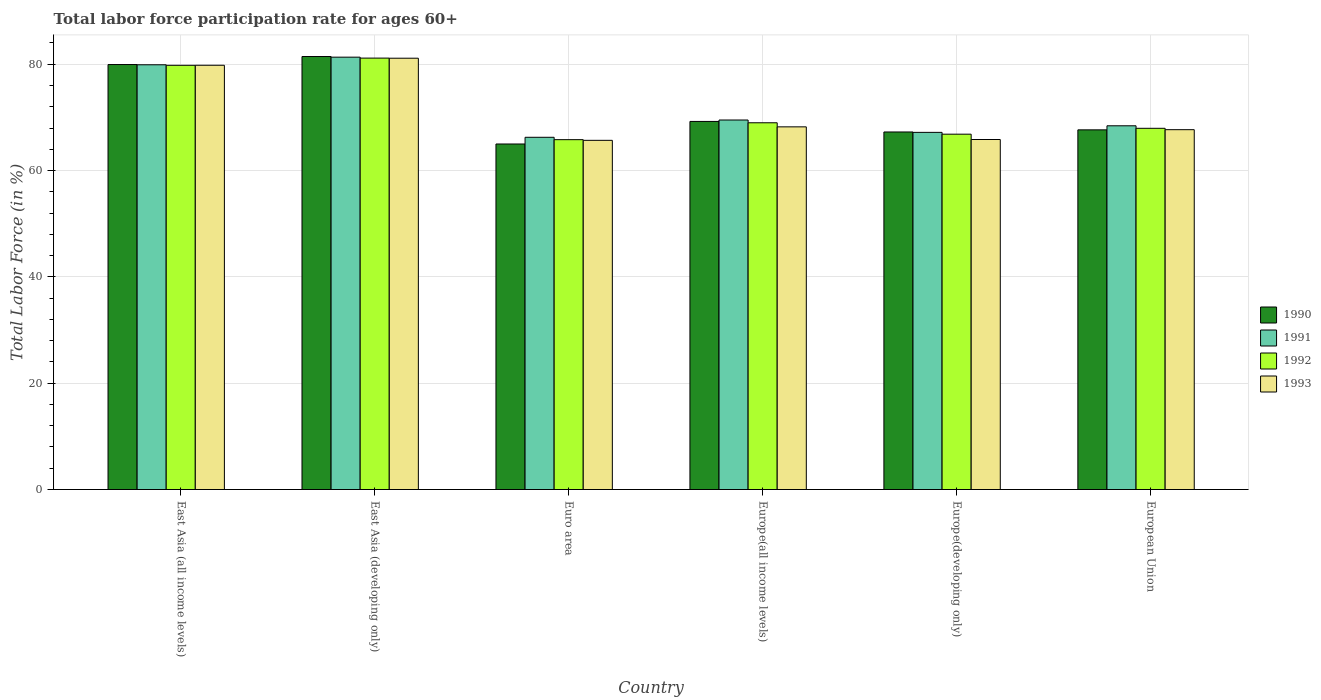How many different coloured bars are there?
Keep it short and to the point. 4. How many groups of bars are there?
Make the answer very short. 6. Are the number of bars per tick equal to the number of legend labels?
Ensure brevity in your answer.  Yes. How many bars are there on the 5th tick from the left?
Give a very brief answer. 4. What is the label of the 2nd group of bars from the left?
Your answer should be very brief. East Asia (developing only). What is the labor force participation rate in 1993 in East Asia (all income levels)?
Make the answer very short. 79.81. Across all countries, what is the maximum labor force participation rate in 1993?
Make the answer very short. 81.14. Across all countries, what is the minimum labor force participation rate in 1990?
Provide a succinct answer. 65. In which country was the labor force participation rate in 1992 maximum?
Keep it short and to the point. East Asia (developing only). In which country was the labor force participation rate in 1993 minimum?
Keep it short and to the point. Euro area. What is the total labor force participation rate in 1993 in the graph?
Offer a very short reply. 428.39. What is the difference between the labor force participation rate in 1992 in East Asia (all income levels) and that in East Asia (developing only)?
Offer a terse response. -1.36. What is the difference between the labor force participation rate in 1992 in Europe(all income levels) and the labor force participation rate in 1993 in East Asia (developing only)?
Provide a succinct answer. -12.15. What is the average labor force participation rate in 1991 per country?
Give a very brief answer. 72.1. What is the difference between the labor force participation rate of/in 1990 and labor force participation rate of/in 1993 in Europe(all income levels)?
Your response must be concise. 1.02. In how many countries, is the labor force participation rate in 1993 greater than 60 %?
Keep it short and to the point. 6. What is the ratio of the labor force participation rate in 1991 in East Asia (all income levels) to that in East Asia (developing only)?
Make the answer very short. 0.98. What is the difference between the highest and the second highest labor force participation rate in 1990?
Give a very brief answer. 12.21. What is the difference between the highest and the lowest labor force participation rate in 1990?
Offer a very short reply. 16.45. What does the 4th bar from the left in Euro area represents?
Offer a very short reply. 1993. Is it the case that in every country, the sum of the labor force participation rate in 1993 and labor force participation rate in 1990 is greater than the labor force participation rate in 1992?
Make the answer very short. Yes. How many bars are there?
Your response must be concise. 24. Are all the bars in the graph horizontal?
Your response must be concise. No. Are the values on the major ticks of Y-axis written in scientific E-notation?
Offer a very short reply. No. Does the graph contain any zero values?
Provide a succinct answer. No. Where does the legend appear in the graph?
Your answer should be compact. Center right. What is the title of the graph?
Ensure brevity in your answer.  Total labor force participation rate for ages 60+. What is the label or title of the Y-axis?
Provide a short and direct response. Total Labor Force (in %). What is the Total Labor Force (in %) in 1990 in East Asia (all income levels)?
Your answer should be compact. 79.95. What is the Total Labor Force (in %) in 1991 in East Asia (all income levels)?
Offer a very short reply. 79.9. What is the Total Labor Force (in %) of 1992 in East Asia (all income levels)?
Provide a succinct answer. 79.8. What is the Total Labor Force (in %) of 1993 in East Asia (all income levels)?
Give a very brief answer. 79.81. What is the Total Labor Force (in %) of 1990 in East Asia (developing only)?
Provide a succinct answer. 81.45. What is the Total Labor Force (in %) of 1991 in East Asia (developing only)?
Provide a succinct answer. 81.33. What is the Total Labor Force (in %) in 1992 in East Asia (developing only)?
Your answer should be compact. 81.16. What is the Total Labor Force (in %) in 1993 in East Asia (developing only)?
Ensure brevity in your answer.  81.14. What is the Total Labor Force (in %) of 1990 in Euro area?
Your response must be concise. 65. What is the Total Labor Force (in %) in 1991 in Euro area?
Provide a succinct answer. 66.26. What is the Total Labor Force (in %) in 1992 in Euro area?
Offer a very short reply. 65.81. What is the Total Labor Force (in %) in 1993 in Euro area?
Provide a succinct answer. 65.69. What is the Total Labor Force (in %) in 1990 in Europe(all income levels)?
Keep it short and to the point. 69.24. What is the Total Labor Force (in %) in 1991 in Europe(all income levels)?
Keep it short and to the point. 69.51. What is the Total Labor Force (in %) in 1992 in Europe(all income levels)?
Ensure brevity in your answer.  68.99. What is the Total Labor Force (in %) in 1993 in Europe(all income levels)?
Offer a very short reply. 68.22. What is the Total Labor Force (in %) in 1990 in Europe(developing only)?
Make the answer very short. 67.26. What is the Total Labor Force (in %) in 1991 in Europe(developing only)?
Provide a short and direct response. 67.19. What is the Total Labor Force (in %) of 1992 in Europe(developing only)?
Offer a terse response. 66.85. What is the Total Labor Force (in %) in 1993 in Europe(developing only)?
Your answer should be very brief. 65.84. What is the Total Labor Force (in %) of 1990 in European Union?
Provide a short and direct response. 67.66. What is the Total Labor Force (in %) in 1991 in European Union?
Keep it short and to the point. 68.42. What is the Total Labor Force (in %) of 1992 in European Union?
Your answer should be compact. 67.95. What is the Total Labor Force (in %) in 1993 in European Union?
Your answer should be compact. 67.69. Across all countries, what is the maximum Total Labor Force (in %) of 1990?
Ensure brevity in your answer.  81.45. Across all countries, what is the maximum Total Labor Force (in %) of 1991?
Your answer should be compact. 81.33. Across all countries, what is the maximum Total Labor Force (in %) in 1992?
Provide a succinct answer. 81.16. Across all countries, what is the maximum Total Labor Force (in %) in 1993?
Keep it short and to the point. 81.14. Across all countries, what is the minimum Total Labor Force (in %) in 1990?
Your response must be concise. 65. Across all countries, what is the minimum Total Labor Force (in %) in 1991?
Keep it short and to the point. 66.26. Across all countries, what is the minimum Total Labor Force (in %) in 1992?
Offer a very short reply. 65.81. Across all countries, what is the minimum Total Labor Force (in %) of 1993?
Your answer should be very brief. 65.69. What is the total Total Labor Force (in %) in 1990 in the graph?
Keep it short and to the point. 430.56. What is the total Total Labor Force (in %) of 1991 in the graph?
Your answer should be very brief. 432.61. What is the total Total Labor Force (in %) of 1992 in the graph?
Your response must be concise. 430.56. What is the total Total Labor Force (in %) in 1993 in the graph?
Ensure brevity in your answer.  428.39. What is the difference between the Total Labor Force (in %) of 1990 in East Asia (all income levels) and that in East Asia (developing only)?
Offer a very short reply. -1.51. What is the difference between the Total Labor Force (in %) of 1991 in East Asia (all income levels) and that in East Asia (developing only)?
Offer a very short reply. -1.43. What is the difference between the Total Labor Force (in %) in 1992 in East Asia (all income levels) and that in East Asia (developing only)?
Make the answer very short. -1.36. What is the difference between the Total Labor Force (in %) of 1993 in East Asia (all income levels) and that in East Asia (developing only)?
Keep it short and to the point. -1.33. What is the difference between the Total Labor Force (in %) of 1990 in East Asia (all income levels) and that in Euro area?
Your answer should be compact. 14.95. What is the difference between the Total Labor Force (in %) in 1991 in East Asia (all income levels) and that in Euro area?
Your response must be concise. 13.64. What is the difference between the Total Labor Force (in %) of 1992 in East Asia (all income levels) and that in Euro area?
Your response must be concise. 13.99. What is the difference between the Total Labor Force (in %) in 1993 in East Asia (all income levels) and that in Euro area?
Provide a short and direct response. 14.12. What is the difference between the Total Labor Force (in %) of 1990 in East Asia (all income levels) and that in Europe(all income levels)?
Ensure brevity in your answer.  10.7. What is the difference between the Total Labor Force (in %) in 1991 in East Asia (all income levels) and that in Europe(all income levels)?
Offer a terse response. 10.39. What is the difference between the Total Labor Force (in %) of 1992 in East Asia (all income levels) and that in Europe(all income levels)?
Offer a very short reply. 10.81. What is the difference between the Total Labor Force (in %) in 1993 in East Asia (all income levels) and that in Europe(all income levels)?
Provide a succinct answer. 11.59. What is the difference between the Total Labor Force (in %) in 1990 in East Asia (all income levels) and that in Europe(developing only)?
Ensure brevity in your answer.  12.69. What is the difference between the Total Labor Force (in %) of 1991 in East Asia (all income levels) and that in Europe(developing only)?
Provide a short and direct response. 12.71. What is the difference between the Total Labor Force (in %) in 1992 in East Asia (all income levels) and that in Europe(developing only)?
Make the answer very short. 12.96. What is the difference between the Total Labor Force (in %) of 1993 in East Asia (all income levels) and that in Europe(developing only)?
Provide a succinct answer. 13.97. What is the difference between the Total Labor Force (in %) of 1990 in East Asia (all income levels) and that in European Union?
Offer a very short reply. 12.29. What is the difference between the Total Labor Force (in %) of 1991 in East Asia (all income levels) and that in European Union?
Your answer should be compact. 11.48. What is the difference between the Total Labor Force (in %) of 1992 in East Asia (all income levels) and that in European Union?
Your response must be concise. 11.85. What is the difference between the Total Labor Force (in %) of 1993 in East Asia (all income levels) and that in European Union?
Your answer should be very brief. 12.12. What is the difference between the Total Labor Force (in %) of 1990 in East Asia (developing only) and that in Euro area?
Give a very brief answer. 16.45. What is the difference between the Total Labor Force (in %) in 1991 in East Asia (developing only) and that in Euro area?
Your answer should be very brief. 15.07. What is the difference between the Total Labor Force (in %) in 1992 in East Asia (developing only) and that in Euro area?
Your answer should be very brief. 15.34. What is the difference between the Total Labor Force (in %) in 1993 in East Asia (developing only) and that in Euro area?
Give a very brief answer. 15.45. What is the difference between the Total Labor Force (in %) in 1990 in East Asia (developing only) and that in Europe(all income levels)?
Offer a terse response. 12.21. What is the difference between the Total Labor Force (in %) in 1991 in East Asia (developing only) and that in Europe(all income levels)?
Your response must be concise. 11.82. What is the difference between the Total Labor Force (in %) of 1992 in East Asia (developing only) and that in Europe(all income levels)?
Your response must be concise. 12.17. What is the difference between the Total Labor Force (in %) in 1993 in East Asia (developing only) and that in Europe(all income levels)?
Your answer should be very brief. 12.91. What is the difference between the Total Labor Force (in %) of 1990 in East Asia (developing only) and that in Europe(developing only)?
Provide a short and direct response. 14.2. What is the difference between the Total Labor Force (in %) of 1991 in East Asia (developing only) and that in Europe(developing only)?
Ensure brevity in your answer.  14.14. What is the difference between the Total Labor Force (in %) in 1992 in East Asia (developing only) and that in Europe(developing only)?
Your answer should be very brief. 14.31. What is the difference between the Total Labor Force (in %) in 1993 in East Asia (developing only) and that in Europe(developing only)?
Offer a very short reply. 15.29. What is the difference between the Total Labor Force (in %) in 1990 in East Asia (developing only) and that in European Union?
Ensure brevity in your answer.  13.79. What is the difference between the Total Labor Force (in %) in 1991 in East Asia (developing only) and that in European Union?
Offer a very short reply. 12.91. What is the difference between the Total Labor Force (in %) of 1992 in East Asia (developing only) and that in European Union?
Offer a terse response. 13.21. What is the difference between the Total Labor Force (in %) in 1993 in East Asia (developing only) and that in European Union?
Offer a very short reply. 13.45. What is the difference between the Total Labor Force (in %) of 1990 in Euro area and that in Europe(all income levels)?
Provide a succinct answer. -4.24. What is the difference between the Total Labor Force (in %) in 1991 in Euro area and that in Europe(all income levels)?
Keep it short and to the point. -3.25. What is the difference between the Total Labor Force (in %) in 1992 in Euro area and that in Europe(all income levels)?
Your response must be concise. -3.18. What is the difference between the Total Labor Force (in %) of 1993 in Euro area and that in Europe(all income levels)?
Your answer should be very brief. -2.54. What is the difference between the Total Labor Force (in %) in 1990 in Euro area and that in Europe(developing only)?
Offer a terse response. -2.26. What is the difference between the Total Labor Force (in %) in 1991 in Euro area and that in Europe(developing only)?
Your response must be concise. -0.93. What is the difference between the Total Labor Force (in %) in 1992 in Euro area and that in Europe(developing only)?
Your answer should be compact. -1.03. What is the difference between the Total Labor Force (in %) in 1993 in Euro area and that in Europe(developing only)?
Ensure brevity in your answer.  -0.16. What is the difference between the Total Labor Force (in %) of 1990 in Euro area and that in European Union?
Give a very brief answer. -2.66. What is the difference between the Total Labor Force (in %) in 1991 in Euro area and that in European Union?
Give a very brief answer. -2.16. What is the difference between the Total Labor Force (in %) of 1992 in Euro area and that in European Union?
Your answer should be compact. -2.14. What is the difference between the Total Labor Force (in %) in 1993 in Euro area and that in European Union?
Your response must be concise. -2.01. What is the difference between the Total Labor Force (in %) in 1990 in Europe(all income levels) and that in Europe(developing only)?
Your answer should be very brief. 1.99. What is the difference between the Total Labor Force (in %) in 1991 in Europe(all income levels) and that in Europe(developing only)?
Provide a short and direct response. 2.33. What is the difference between the Total Labor Force (in %) of 1992 in Europe(all income levels) and that in Europe(developing only)?
Offer a very short reply. 2.15. What is the difference between the Total Labor Force (in %) of 1993 in Europe(all income levels) and that in Europe(developing only)?
Provide a short and direct response. 2.38. What is the difference between the Total Labor Force (in %) of 1990 in Europe(all income levels) and that in European Union?
Offer a terse response. 1.58. What is the difference between the Total Labor Force (in %) of 1991 in Europe(all income levels) and that in European Union?
Offer a very short reply. 1.09. What is the difference between the Total Labor Force (in %) in 1992 in Europe(all income levels) and that in European Union?
Give a very brief answer. 1.04. What is the difference between the Total Labor Force (in %) in 1993 in Europe(all income levels) and that in European Union?
Your response must be concise. 0.53. What is the difference between the Total Labor Force (in %) in 1990 in Europe(developing only) and that in European Union?
Provide a short and direct response. -0.4. What is the difference between the Total Labor Force (in %) of 1991 in Europe(developing only) and that in European Union?
Ensure brevity in your answer.  -1.24. What is the difference between the Total Labor Force (in %) in 1992 in Europe(developing only) and that in European Union?
Your answer should be compact. -1.1. What is the difference between the Total Labor Force (in %) in 1993 in Europe(developing only) and that in European Union?
Keep it short and to the point. -1.85. What is the difference between the Total Labor Force (in %) of 1990 in East Asia (all income levels) and the Total Labor Force (in %) of 1991 in East Asia (developing only)?
Make the answer very short. -1.39. What is the difference between the Total Labor Force (in %) in 1990 in East Asia (all income levels) and the Total Labor Force (in %) in 1992 in East Asia (developing only)?
Make the answer very short. -1.21. What is the difference between the Total Labor Force (in %) of 1990 in East Asia (all income levels) and the Total Labor Force (in %) of 1993 in East Asia (developing only)?
Your answer should be very brief. -1.19. What is the difference between the Total Labor Force (in %) in 1991 in East Asia (all income levels) and the Total Labor Force (in %) in 1992 in East Asia (developing only)?
Make the answer very short. -1.26. What is the difference between the Total Labor Force (in %) in 1991 in East Asia (all income levels) and the Total Labor Force (in %) in 1993 in East Asia (developing only)?
Your response must be concise. -1.24. What is the difference between the Total Labor Force (in %) of 1992 in East Asia (all income levels) and the Total Labor Force (in %) of 1993 in East Asia (developing only)?
Offer a very short reply. -1.34. What is the difference between the Total Labor Force (in %) in 1990 in East Asia (all income levels) and the Total Labor Force (in %) in 1991 in Euro area?
Offer a terse response. 13.69. What is the difference between the Total Labor Force (in %) in 1990 in East Asia (all income levels) and the Total Labor Force (in %) in 1992 in Euro area?
Your answer should be compact. 14.13. What is the difference between the Total Labor Force (in %) in 1990 in East Asia (all income levels) and the Total Labor Force (in %) in 1993 in Euro area?
Give a very brief answer. 14.26. What is the difference between the Total Labor Force (in %) of 1991 in East Asia (all income levels) and the Total Labor Force (in %) of 1992 in Euro area?
Offer a very short reply. 14.09. What is the difference between the Total Labor Force (in %) of 1991 in East Asia (all income levels) and the Total Labor Force (in %) of 1993 in Euro area?
Your answer should be compact. 14.22. What is the difference between the Total Labor Force (in %) in 1992 in East Asia (all income levels) and the Total Labor Force (in %) in 1993 in Euro area?
Your answer should be compact. 14.12. What is the difference between the Total Labor Force (in %) of 1990 in East Asia (all income levels) and the Total Labor Force (in %) of 1991 in Europe(all income levels)?
Your answer should be compact. 10.43. What is the difference between the Total Labor Force (in %) in 1990 in East Asia (all income levels) and the Total Labor Force (in %) in 1992 in Europe(all income levels)?
Your answer should be compact. 10.95. What is the difference between the Total Labor Force (in %) of 1990 in East Asia (all income levels) and the Total Labor Force (in %) of 1993 in Europe(all income levels)?
Provide a short and direct response. 11.72. What is the difference between the Total Labor Force (in %) in 1991 in East Asia (all income levels) and the Total Labor Force (in %) in 1992 in Europe(all income levels)?
Provide a succinct answer. 10.91. What is the difference between the Total Labor Force (in %) of 1991 in East Asia (all income levels) and the Total Labor Force (in %) of 1993 in Europe(all income levels)?
Give a very brief answer. 11.68. What is the difference between the Total Labor Force (in %) in 1992 in East Asia (all income levels) and the Total Labor Force (in %) in 1993 in Europe(all income levels)?
Make the answer very short. 11.58. What is the difference between the Total Labor Force (in %) of 1990 in East Asia (all income levels) and the Total Labor Force (in %) of 1991 in Europe(developing only)?
Give a very brief answer. 12.76. What is the difference between the Total Labor Force (in %) in 1990 in East Asia (all income levels) and the Total Labor Force (in %) in 1992 in Europe(developing only)?
Your response must be concise. 13.1. What is the difference between the Total Labor Force (in %) in 1990 in East Asia (all income levels) and the Total Labor Force (in %) in 1993 in Europe(developing only)?
Your answer should be very brief. 14.1. What is the difference between the Total Labor Force (in %) of 1991 in East Asia (all income levels) and the Total Labor Force (in %) of 1992 in Europe(developing only)?
Give a very brief answer. 13.05. What is the difference between the Total Labor Force (in %) in 1991 in East Asia (all income levels) and the Total Labor Force (in %) in 1993 in Europe(developing only)?
Give a very brief answer. 14.06. What is the difference between the Total Labor Force (in %) of 1992 in East Asia (all income levels) and the Total Labor Force (in %) of 1993 in Europe(developing only)?
Provide a succinct answer. 13.96. What is the difference between the Total Labor Force (in %) in 1990 in East Asia (all income levels) and the Total Labor Force (in %) in 1991 in European Union?
Your answer should be compact. 11.52. What is the difference between the Total Labor Force (in %) of 1990 in East Asia (all income levels) and the Total Labor Force (in %) of 1992 in European Union?
Offer a terse response. 11.99. What is the difference between the Total Labor Force (in %) in 1990 in East Asia (all income levels) and the Total Labor Force (in %) in 1993 in European Union?
Your response must be concise. 12.25. What is the difference between the Total Labor Force (in %) of 1991 in East Asia (all income levels) and the Total Labor Force (in %) of 1992 in European Union?
Offer a terse response. 11.95. What is the difference between the Total Labor Force (in %) of 1991 in East Asia (all income levels) and the Total Labor Force (in %) of 1993 in European Union?
Give a very brief answer. 12.21. What is the difference between the Total Labor Force (in %) of 1992 in East Asia (all income levels) and the Total Labor Force (in %) of 1993 in European Union?
Ensure brevity in your answer.  12.11. What is the difference between the Total Labor Force (in %) in 1990 in East Asia (developing only) and the Total Labor Force (in %) in 1991 in Euro area?
Give a very brief answer. 15.19. What is the difference between the Total Labor Force (in %) in 1990 in East Asia (developing only) and the Total Labor Force (in %) in 1992 in Euro area?
Provide a short and direct response. 15.64. What is the difference between the Total Labor Force (in %) of 1990 in East Asia (developing only) and the Total Labor Force (in %) of 1993 in Euro area?
Your answer should be compact. 15.77. What is the difference between the Total Labor Force (in %) in 1991 in East Asia (developing only) and the Total Labor Force (in %) in 1992 in Euro area?
Make the answer very short. 15.52. What is the difference between the Total Labor Force (in %) of 1991 in East Asia (developing only) and the Total Labor Force (in %) of 1993 in Euro area?
Offer a very short reply. 15.65. What is the difference between the Total Labor Force (in %) in 1992 in East Asia (developing only) and the Total Labor Force (in %) in 1993 in Euro area?
Offer a terse response. 15.47. What is the difference between the Total Labor Force (in %) of 1990 in East Asia (developing only) and the Total Labor Force (in %) of 1991 in Europe(all income levels)?
Give a very brief answer. 11.94. What is the difference between the Total Labor Force (in %) of 1990 in East Asia (developing only) and the Total Labor Force (in %) of 1992 in Europe(all income levels)?
Keep it short and to the point. 12.46. What is the difference between the Total Labor Force (in %) of 1990 in East Asia (developing only) and the Total Labor Force (in %) of 1993 in Europe(all income levels)?
Provide a short and direct response. 13.23. What is the difference between the Total Labor Force (in %) of 1991 in East Asia (developing only) and the Total Labor Force (in %) of 1992 in Europe(all income levels)?
Keep it short and to the point. 12.34. What is the difference between the Total Labor Force (in %) in 1991 in East Asia (developing only) and the Total Labor Force (in %) in 1993 in Europe(all income levels)?
Offer a very short reply. 13.11. What is the difference between the Total Labor Force (in %) in 1992 in East Asia (developing only) and the Total Labor Force (in %) in 1993 in Europe(all income levels)?
Your answer should be compact. 12.93. What is the difference between the Total Labor Force (in %) in 1990 in East Asia (developing only) and the Total Labor Force (in %) in 1991 in Europe(developing only)?
Provide a succinct answer. 14.27. What is the difference between the Total Labor Force (in %) of 1990 in East Asia (developing only) and the Total Labor Force (in %) of 1992 in Europe(developing only)?
Your response must be concise. 14.61. What is the difference between the Total Labor Force (in %) in 1990 in East Asia (developing only) and the Total Labor Force (in %) in 1993 in Europe(developing only)?
Give a very brief answer. 15.61. What is the difference between the Total Labor Force (in %) in 1991 in East Asia (developing only) and the Total Labor Force (in %) in 1992 in Europe(developing only)?
Give a very brief answer. 14.49. What is the difference between the Total Labor Force (in %) of 1991 in East Asia (developing only) and the Total Labor Force (in %) of 1993 in Europe(developing only)?
Make the answer very short. 15.49. What is the difference between the Total Labor Force (in %) of 1992 in East Asia (developing only) and the Total Labor Force (in %) of 1993 in Europe(developing only)?
Your response must be concise. 15.31. What is the difference between the Total Labor Force (in %) of 1990 in East Asia (developing only) and the Total Labor Force (in %) of 1991 in European Union?
Your answer should be compact. 13.03. What is the difference between the Total Labor Force (in %) in 1990 in East Asia (developing only) and the Total Labor Force (in %) in 1992 in European Union?
Ensure brevity in your answer.  13.5. What is the difference between the Total Labor Force (in %) of 1990 in East Asia (developing only) and the Total Labor Force (in %) of 1993 in European Union?
Your answer should be very brief. 13.76. What is the difference between the Total Labor Force (in %) of 1991 in East Asia (developing only) and the Total Labor Force (in %) of 1992 in European Union?
Your answer should be compact. 13.38. What is the difference between the Total Labor Force (in %) of 1991 in East Asia (developing only) and the Total Labor Force (in %) of 1993 in European Union?
Make the answer very short. 13.64. What is the difference between the Total Labor Force (in %) of 1992 in East Asia (developing only) and the Total Labor Force (in %) of 1993 in European Union?
Offer a terse response. 13.47. What is the difference between the Total Labor Force (in %) in 1990 in Euro area and the Total Labor Force (in %) in 1991 in Europe(all income levels)?
Keep it short and to the point. -4.51. What is the difference between the Total Labor Force (in %) of 1990 in Euro area and the Total Labor Force (in %) of 1992 in Europe(all income levels)?
Ensure brevity in your answer.  -3.99. What is the difference between the Total Labor Force (in %) of 1990 in Euro area and the Total Labor Force (in %) of 1993 in Europe(all income levels)?
Give a very brief answer. -3.22. What is the difference between the Total Labor Force (in %) of 1991 in Euro area and the Total Labor Force (in %) of 1992 in Europe(all income levels)?
Make the answer very short. -2.73. What is the difference between the Total Labor Force (in %) of 1991 in Euro area and the Total Labor Force (in %) of 1993 in Europe(all income levels)?
Offer a very short reply. -1.97. What is the difference between the Total Labor Force (in %) in 1992 in Euro area and the Total Labor Force (in %) in 1993 in Europe(all income levels)?
Make the answer very short. -2.41. What is the difference between the Total Labor Force (in %) of 1990 in Euro area and the Total Labor Force (in %) of 1991 in Europe(developing only)?
Make the answer very short. -2.19. What is the difference between the Total Labor Force (in %) in 1990 in Euro area and the Total Labor Force (in %) in 1992 in Europe(developing only)?
Offer a very short reply. -1.85. What is the difference between the Total Labor Force (in %) of 1990 in Euro area and the Total Labor Force (in %) of 1993 in Europe(developing only)?
Provide a succinct answer. -0.84. What is the difference between the Total Labor Force (in %) in 1991 in Euro area and the Total Labor Force (in %) in 1992 in Europe(developing only)?
Your response must be concise. -0.59. What is the difference between the Total Labor Force (in %) in 1991 in Euro area and the Total Labor Force (in %) in 1993 in Europe(developing only)?
Ensure brevity in your answer.  0.42. What is the difference between the Total Labor Force (in %) in 1992 in Euro area and the Total Labor Force (in %) in 1993 in Europe(developing only)?
Ensure brevity in your answer.  -0.03. What is the difference between the Total Labor Force (in %) in 1990 in Euro area and the Total Labor Force (in %) in 1991 in European Union?
Your answer should be compact. -3.42. What is the difference between the Total Labor Force (in %) of 1990 in Euro area and the Total Labor Force (in %) of 1992 in European Union?
Ensure brevity in your answer.  -2.95. What is the difference between the Total Labor Force (in %) of 1990 in Euro area and the Total Labor Force (in %) of 1993 in European Union?
Ensure brevity in your answer.  -2.69. What is the difference between the Total Labor Force (in %) in 1991 in Euro area and the Total Labor Force (in %) in 1992 in European Union?
Provide a succinct answer. -1.69. What is the difference between the Total Labor Force (in %) of 1991 in Euro area and the Total Labor Force (in %) of 1993 in European Union?
Provide a succinct answer. -1.43. What is the difference between the Total Labor Force (in %) in 1992 in Euro area and the Total Labor Force (in %) in 1993 in European Union?
Your response must be concise. -1.88. What is the difference between the Total Labor Force (in %) in 1990 in Europe(all income levels) and the Total Labor Force (in %) in 1991 in Europe(developing only)?
Offer a very short reply. 2.06. What is the difference between the Total Labor Force (in %) of 1990 in Europe(all income levels) and the Total Labor Force (in %) of 1992 in Europe(developing only)?
Offer a very short reply. 2.4. What is the difference between the Total Labor Force (in %) in 1990 in Europe(all income levels) and the Total Labor Force (in %) in 1993 in Europe(developing only)?
Give a very brief answer. 3.4. What is the difference between the Total Labor Force (in %) in 1991 in Europe(all income levels) and the Total Labor Force (in %) in 1992 in Europe(developing only)?
Provide a short and direct response. 2.67. What is the difference between the Total Labor Force (in %) in 1991 in Europe(all income levels) and the Total Labor Force (in %) in 1993 in Europe(developing only)?
Your response must be concise. 3.67. What is the difference between the Total Labor Force (in %) in 1992 in Europe(all income levels) and the Total Labor Force (in %) in 1993 in Europe(developing only)?
Your answer should be very brief. 3.15. What is the difference between the Total Labor Force (in %) of 1990 in Europe(all income levels) and the Total Labor Force (in %) of 1991 in European Union?
Your answer should be very brief. 0.82. What is the difference between the Total Labor Force (in %) of 1990 in Europe(all income levels) and the Total Labor Force (in %) of 1992 in European Union?
Your answer should be very brief. 1.29. What is the difference between the Total Labor Force (in %) of 1990 in Europe(all income levels) and the Total Labor Force (in %) of 1993 in European Union?
Make the answer very short. 1.55. What is the difference between the Total Labor Force (in %) in 1991 in Europe(all income levels) and the Total Labor Force (in %) in 1992 in European Union?
Offer a terse response. 1.56. What is the difference between the Total Labor Force (in %) of 1991 in Europe(all income levels) and the Total Labor Force (in %) of 1993 in European Union?
Offer a very short reply. 1.82. What is the difference between the Total Labor Force (in %) in 1992 in Europe(all income levels) and the Total Labor Force (in %) in 1993 in European Union?
Provide a succinct answer. 1.3. What is the difference between the Total Labor Force (in %) in 1990 in Europe(developing only) and the Total Labor Force (in %) in 1991 in European Union?
Offer a very short reply. -1.16. What is the difference between the Total Labor Force (in %) of 1990 in Europe(developing only) and the Total Labor Force (in %) of 1992 in European Union?
Provide a short and direct response. -0.69. What is the difference between the Total Labor Force (in %) in 1990 in Europe(developing only) and the Total Labor Force (in %) in 1993 in European Union?
Offer a terse response. -0.43. What is the difference between the Total Labor Force (in %) of 1991 in Europe(developing only) and the Total Labor Force (in %) of 1992 in European Union?
Your response must be concise. -0.76. What is the difference between the Total Labor Force (in %) of 1991 in Europe(developing only) and the Total Labor Force (in %) of 1993 in European Union?
Ensure brevity in your answer.  -0.51. What is the difference between the Total Labor Force (in %) of 1992 in Europe(developing only) and the Total Labor Force (in %) of 1993 in European Union?
Offer a terse response. -0.85. What is the average Total Labor Force (in %) in 1990 per country?
Make the answer very short. 71.76. What is the average Total Labor Force (in %) in 1991 per country?
Provide a succinct answer. 72.1. What is the average Total Labor Force (in %) of 1992 per country?
Provide a short and direct response. 71.76. What is the average Total Labor Force (in %) of 1993 per country?
Ensure brevity in your answer.  71.4. What is the difference between the Total Labor Force (in %) of 1990 and Total Labor Force (in %) of 1991 in East Asia (all income levels)?
Give a very brief answer. 0.04. What is the difference between the Total Labor Force (in %) of 1990 and Total Labor Force (in %) of 1992 in East Asia (all income levels)?
Keep it short and to the point. 0.14. What is the difference between the Total Labor Force (in %) in 1990 and Total Labor Force (in %) in 1993 in East Asia (all income levels)?
Keep it short and to the point. 0.14. What is the difference between the Total Labor Force (in %) of 1991 and Total Labor Force (in %) of 1992 in East Asia (all income levels)?
Your answer should be very brief. 0.1. What is the difference between the Total Labor Force (in %) in 1991 and Total Labor Force (in %) in 1993 in East Asia (all income levels)?
Make the answer very short. 0.09. What is the difference between the Total Labor Force (in %) of 1992 and Total Labor Force (in %) of 1993 in East Asia (all income levels)?
Provide a short and direct response. -0.01. What is the difference between the Total Labor Force (in %) of 1990 and Total Labor Force (in %) of 1991 in East Asia (developing only)?
Provide a succinct answer. 0.12. What is the difference between the Total Labor Force (in %) in 1990 and Total Labor Force (in %) in 1992 in East Asia (developing only)?
Offer a terse response. 0.3. What is the difference between the Total Labor Force (in %) of 1990 and Total Labor Force (in %) of 1993 in East Asia (developing only)?
Keep it short and to the point. 0.32. What is the difference between the Total Labor Force (in %) of 1991 and Total Labor Force (in %) of 1992 in East Asia (developing only)?
Your answer should be very brief. 0.17. What is the difference between the Total Labor Force (in %) in 1991 and Total Labor Force (in %) in 1993 in East Asia (developing only)?
Your answer should be compact. 0.19. What is the difference between the Total Labor Force (in %) of 1992 and Total Labor Force (in %) of 1993 in East Asia (developing only)?
Offer a very short reply. 0.02. What is the difference between the Total Labor Force (in %) of 1990 and Total Labor Force (in %) of 1991 in Euro area?
Your response must be concise. -1.26. What is the difference between the Total Labor Force (in %) of 1990 and Total Labor Force (in %) of 1992 in Euro area?
Your answer should be compact. -0.81. What is the difference between the Total Labor Force (in %) of 1990 and Total Labor Force (in %) of 1993 in Euro area?
Provide a succinct answer. -0.69. What is the difference between the Total Labor Force (in %) in 1991 and Total Labor Force (in %) in 1992 in Euro area?
Ensure brevity in your answer.  0.45. What is the difference between the Total Labor Force (in %) in 1991 and Total Labor Force (in %) in 1993 in Euro area?
Ensure brevity in your answer.  0.57. What is the difference between the Total Labor Force (in %) in 1992 and Total Labor Force (in %) in 1993 in Euro area?
Provide a succinct answer. 0.13. What is the difference between the Total Labor Force (in %) of 1990 and Total Labor Force (in %) of 1991 in Europe(all income levels)?
Provide a succinct answer. -0.27. What is the difference between the Total Labor Force (in %) of 1990 and Total Labor Force (in %) of 1992 in Europe(all income levels)?
Your answer should be compact. 0.25. What is the difference between the Total Labor Force (in %) of 1990 and Total Labor Force (in %) of 1993 in Europe(all income levels)?
Your answer should be very brief. 1.02. What is the difference between the Total Labor Force (in %) in 1991 and Total Labor Force (in %) in 1992 in Europe(all income levels)?
Ensure brevity in your answer.  0.52. What is the difference between the Total Labor Force (in %) of 1991 and Total Labor Force (in %) of 1993 in Europe(all income levels)?
Offer a terse response. 1.29. What is the difference between the Total Labor Force (in %) of 1992 and Total Labor Force (in %) of 1993 in Europe(all income levels)?
Offer a terse response. 0.77. What is the difference between the Total Labor Force (in %) in 1990 and Total Labor Force (in %) in 1991 in Europe(developing only)?
Offer a very short reply. 0.07. What is the difference between the Total Labor Force (in %) of 1990 and Total Labor Force (in %) of 1992 in Europe(developing only)?
Give a very brief answer. 0.41. What is the difference between the Total Labor Force (in %) in 1990 and Total Labor Force (in %) in 1993 in Europe(developing only)?
Your answer should be very brief. 1.42. What is the difference between the Total Labor Force (in %) in 1991 and Total Labor Force (in %) in 1992 in Europe(developing only)?
Offer a terse response. 0.34. What is the difference between the Total Labor Force (in %) of 1991 and Total Labor Force (in %) of 1993 in Europe(developing only)?
Offer a terse response. 1.34. What is the difference between the Total Labor Force (in %) in 1990 and Total Labor Force (in %) in 1991 in European Union?
Ensure brevity in your answer.  -0.76. What is the difference between the Total Labor Force (in %) in 1990 and Total Labor Force (in %) in 1992 in European Union?
Provide a succinct answer. -0.29. What is the difference between the Total Labor Force (in %) in 1990 and Total Labor Force (in %) in 1993 in European Union?
Ensure brevity in your answer.  -0.03. What is the difference between the Total Labor Force (in %) of 1991 and Total Labor Force (in %) of 1992 in European Union?
Offer a very short reply. 0.47. What is the difference between the Total Labor Force (in %) of 1991 and Total Labor Force (in %) of 1993 in European Union?
Your answer should be very brief. 0.73. What is the difference between the Total Labor Force (in %) in 1992 and Total Labor Force (in %) in 1993 in European Union?
Your answer should be very brief. 0.26. What is the ratio of the Total Labor Force (in %) of 1990 in East Asia (all income levels) to that in East Asia (developing only)?
Your answer should be very brief. 0.98. What is the ratio of the Total Labor Force (in %) in 1991 in East Asia (all income levels) to that in East Asia (developing only)?
Provide a short and direct response. 0.98. What is the ratio of the Total Labor Force (in %) of 1992 in East Asia (all income levels) to that in East Asia (developing only)?
Your response must be concise. 0.98. What is the ratio of the Total Labor Force (in %) of 1993 in East Asia (all income levels) to that in East Asia (developing only)?
Your response must be concise. 0.98. What is the ratio of the Total Labor Force (in %) in 1990 in East Asia (all income levels) to that in Euro area?
Ensure brevity in your answer.  1.23. What is the ratio of the Total Labor Force (in %) in 1991 in East Asia (all income levels) to that in Euro area?
Give a very brief answer. 1.21. What is the ratio of the Total Labor Force (in %) in 1992 in East Asia (all income levels) to that in Euro area?
Offer a terse response. 1.21. What is the ratio of the Total Labor Force (in %) of 1993 in East Asia (all income levels) to that in Euro area?
Keep it short and to the point. 1.22. What is the ratio of the Total Labor Force (in %) in 1990 in East Asia (all income levels) to that in Europe(all income levels)?
Make the answer very short. 1.15. What is the ratio of the Total Labor Force (in %) of 1991 in East Asia (all income levels) to that in Europe(all income levels)?
Make the answer very short. 1.15. What is the ratio of the Total Labor Force (in %) of 1992 in East Asia (all income levels) to that in Europe(all income levels)?
Your answer should be compact. 1.16. What is the ratio of the Total Labor Force (in %) in 1993 in East Asia (all income levels) to that in Europe(all income levels)?
Provide a succinct answer. 1.17. What is the ratio of the Total Labor Force (in %) of 1990 in East Asia (all income levels) to that in Europe(developing only)?
Provide a short and direct response. 1.19. What is the ratio of the Total Labor Force (in %) in 1991 in East Asia (all income levels) to that in Europe(developing only)?
Give a very brief answer. 1.19. What is the ratio of the Total Labor Force (in %) of 1992 in East Asia (all income levels) to that in Europe(developing only)?
Provide a short and direct response. 1.19. What is the ratio of the Total Labor Force (in %) in 1993 in East Asia (all income levels) to that in Europe(developing only)?
Make the answer very short. 1.21. What is the ratio of the Total Labor Force (in %) of 1990 in East Asia (all income levels) to that in European Union?
Offer a terse response. 1.18. What is the ratio of the Total Labor Force (in %) in 1991 in East Asia (all income levels) to that in European Union?
Provide a succinct answer. 1.17. What is the ratio of the Total Labor Force (in %) of 1992 in East Asia (all income levels) to that in European Union?
Offer a terse response. 1.17. What is the ratio of the Total Labor Force (in %) of 1993 in East Asia (all income levels) to that in European Union?
Provide a succinct answer. 1.18. What is the ratio of the Total Labor Force (in %) in 1990 in East Asia (developing only) to that in Euro area?
Your response must be concise. 1.25. What is the ratio of the Total Labor Force (in %) of 1991 in East Asia (developing only) to that in Euro area?
Give a very brief answer. 1.23. What is the ratio of the Total Labor Force (in %) in 1992 in East Asia (developing only) to that in Euro area?
Your answer should be compact. 1.23. What is the ratio of the Total Labor Force (in %) in 1993 in East Asia (developing only) to that in Euro area?
Your answer should be compact. 1.24. What is the ratio of the Total Labor Force (in %) of 1990 in East Asia (developing only) to that in Europe(all income levels)?
Make the answer very short. 1.18. What is the ratio of the Total Labor Force (in %) of 1991 in East Asia (developing only) to that in Europe(all income levels)?
Your response must be concise. 1.17. What is the ratio of the Total Labor Force (in %) of 1992 in East Asia (developing only) to that in Europe(all income levels)?
Provide a short and direct response. 1.18. What is the ratio of the Total Labor Force (in %) in 1993 in East Asia (developing only) to that in Europe(all income levels)?
Give a very brief answer. 1.19. What is the ratio of the Total Labor Force (in %) of 1990 in East Asia (developing only) to that in Europe(developing only)?
Give a very brief answer. 1.21. What is the ratio of the Total Labor Force (in %) in 1991 in East Asia (developing only) to that in Europe(developing only)?
Your answer should be very brief. 1.21. What is the ratio of the Total Labor Force (in %) in 1992 in East Asia (developing only) to that in Europe(developing only)?
Your answer should be compact. 1.21. What is the ratio of the Total Labor Force (in %) of 1993 in East Asia (developing only) to that in Europe(developing only)?
Your response must be concise. 1.23. What is the ratio of the Total Labor Force (in %) in 1990 in East Asia (developing only) to that in European Union?
Provide a short and direct response. 1.2. What is the ratio of the Total Labor Force (in %) of 1991 in East Asia (developing only) to that in European Union?
Ensure brevity in your answer.  1.19. What is the ratio of the Total Labor Force (in %) of 1992 in East Asia (developing only) to that in European Union?
Keep it short and to the point. 1.19. What is the ratio of the Total Labor Force (in %) in 1993 in East Asia (developing only) to that in European Union?
Ensure brevity in your answer.  1.2. What is the ratio of the Total Labor Force (in %) in 1990 in Euro area to that in Europe(all income levels)?
Give a very brief answer. 0.94. What is the ratio of the Total Labor Force (in %) of 1991 in Euro area to that in Europe(all income levels)?
Make the answer very short. 0.95. What is the ratio of the Total Labor Force (in %) in 1992 in Euro area to that in Europe(all income levels)?
Offer a very short reply. 0.95. What is the ratio of the Total Labor Force (in %) of 1993 in Euro area to that in Europe(all income levels)?
Your answer should be very brief. 0.96. What is the ratio of the Total Labor Force (in %) of 1990 in Euro area to that in Europe(developing only)?
Give a very brief answer. 0.97. What is the ratio of the Total Labor Force (in %) in 1991 in Euro area to that in Europe(developing only)?
Keep it short and to the point. 0.99. What is the ratio of the Total Labor Force (in %) in 1992 in Euro area to that in Europe(developing only)?
Provide a short and direct response. 0.98. What is the ratio of the Total Labor Force (in %) of 1990 in Euro area to that in European Union?
Provide a short and direct response. 0.96. What is the ratio of the Total Labor Force (in %) of 1991 in Euro area to that in European Union?
Offer a terse response. 0.97. What is the ratio of the Total Labor Force (in %) of 1992 in Euro area to that in European Union?
Provide a succinct answer. 0.97. What is the ratio of the Total Labor Force (in %) in 1993 in Euro area to that in European Union?
Provide a succinct answer. 0.97. What is the ratio of the Total Labor Force (in %) of 1990 in Europe(all income levels) to that in Europe(developing only)?
Provide a succinct answer. 1.03. What is the ratio of the Total Labor Force (in %) in 1991 in Europe(all income levels) to that in Europe(developing only)?
Your answer should be very brief. 1.03. What is the ratio of the Total Labor Force (in %) of 1992 in Europe(all income levels) to that in Europe(developing only)?
Your response must be concise. 1.03. What is the ratio of the Total Labor Force (in %) in 1993 in Europe(all income levels) to that in Europe(developing only)?
Offer a terse response. 1.04. What is the ratio of the Total Labor Force (in %) in 1990 in Europe(all income levels) to that in European Union?
Offer a very short reply. 1.02. What is the ratio of the Total Labor Force (in %) in 1991 in Europe(all income levels) to that in European Union?
Give a very brief answer. 1.02. What is the ratio of the Total Labor Force (in %) in 1992 in Europe(all income levels) to that in European Union?
Make the answer very short. 1.02. What is the ratio of the Total Labor Force (in %) of 1993 in Europe(all income levels) to that in European Union?
Make the answer very short. 1.01. What is the ratio of the Total Labor Force (in %) in 1991 in Europe(developing only) to that in European Union?
Ensure brevity in your answer.  0.98. What is the ratio of the Total Labor Force (in %) of 1992 in Europe(developing only) to that in European Union?
Ensure brevity in your answer.  0.98. What is the ratio of the Total Labor Force (in %) of 1993 in Europe(developing only) to that in European Union?
Your response must be concise. 0.97. What is the difference between the highest and the second highest Total Labor Force (in %) of 1990?
Make the answer very short. 1.51. What is the difference between the highest and the second highest Total Labor Force (in %) of 1991?
Offer a terse response. 1.43. What is the difference between the highest and the second highest Total Labor Force (in %) in 1992?
Ensure brevity in your answer.  1.36. What is the difference between the highest and the second highest Total Labor Force (in %) of 1993?
Your answer should be compact. 1.33. What is the difference between the highest and the lowest Total Labor Force (in %) in 1990?
Give a very brief answer. 16.45. What is the difference between the highest and the lowest Total Labor Force (in %) of 1991?
Provide a short and direct response. 15.07. What is the difference between the highest and the lowest Total Labor Force (in %) in 1992?
Ensure brevity in your answer.  15.34. What is the difference between the highest and the lowest Total Labor Force (in %) of 1993?
Your response must be concise. 15.45. 